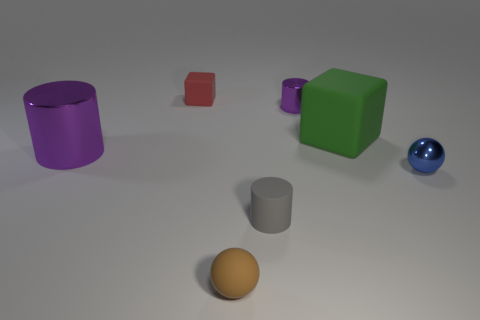What is the shape of the small brown matte object? The small brown object appears to have a dome shape, resembling half of a sphere or a hemisphere, resting flat on the surface. 